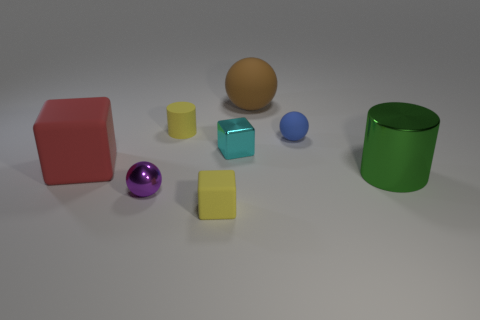What material is the small object that is the same color as the tiny rubber cube?
Your answer should be compact. Rubber. How many other things are there of the same shape as the blue object?
Keep it short and to the point. 2. The thing that is both on the right side of the yellow cylinder and behind the small matte ball is made of what material?
Your answer should be compact. Rubber. What number of objects are either large green spheres or shiny cubes?
Keep it short and to the point. 1. Are there more brown spheres than small brown rubber blocks?
Make the answer very short. Yes. There is a thing that is in front of the small metallic object that is left of the tiny yellow matte cylinder; what size is it?
Offer a very short reply. Small. What is the color of the matte object that is the same shape as the large metallic thing?
Offer a very short reply. Yellow. What is the size of the green metal cylinder?
Give a very brief answer. Large. How many cubes are large objects or small cyan things?
Provide a short and direct response. 2. What is the size of the purple thing that is the same shape as the blue thing?
Offer a terse response. Small. 